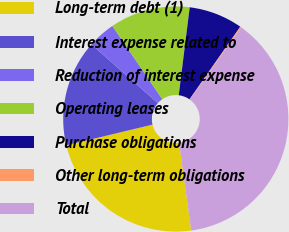<chart> <loc_0><loc_0><loc_500><loc_500><pie_chart><fcel>Long-term debt (1)<fcel>Interest expense related to<fcel>Reduction of interest expense<fcel>Operating leases<fcel>Purchase obligations<fcel>Other long-term obligations<fcel>Total<nl><fcel>23.44%<fcel>15.28%<fcel>3.95%<fcel>11.5%<fcel>7.73%<fcel>0.18%<fcel>37.92%<nl></chart> 